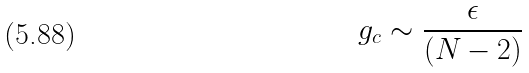Convert formula to latex. <formula><loc_0><loc_0><loc_500><loc_500>g _ { c } \sim \frac { \epsilon } { ( N - 2 ) }</formula> 